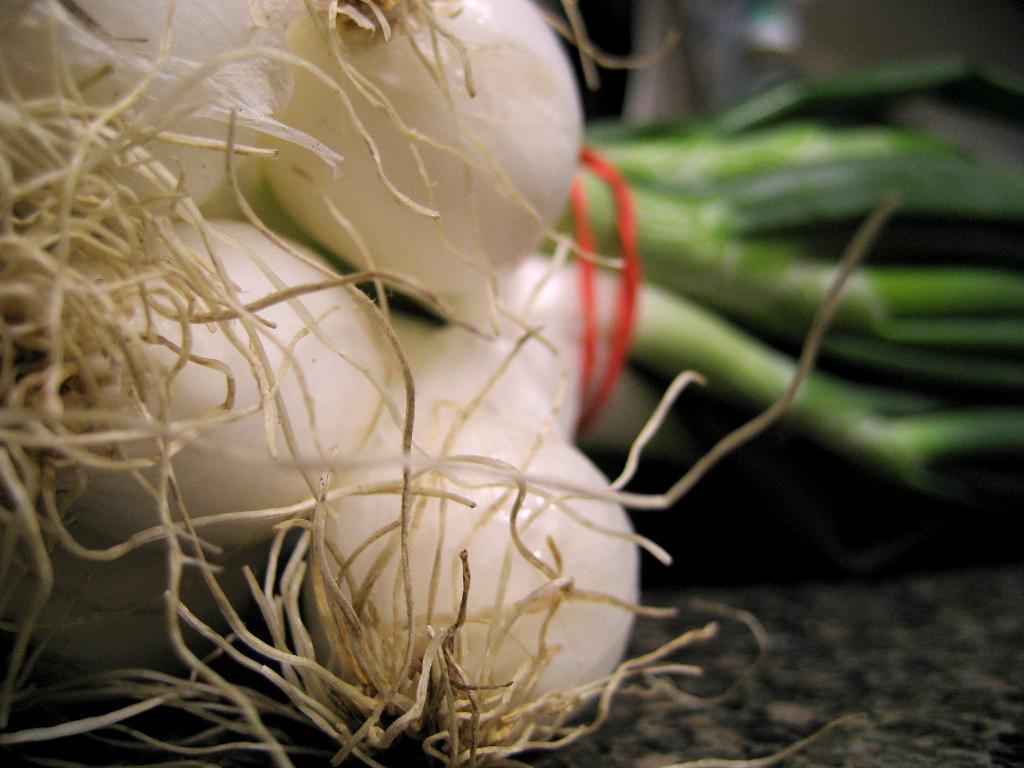Can you describe this image briefly? We can see onions on the platform. In the background it is blur. 